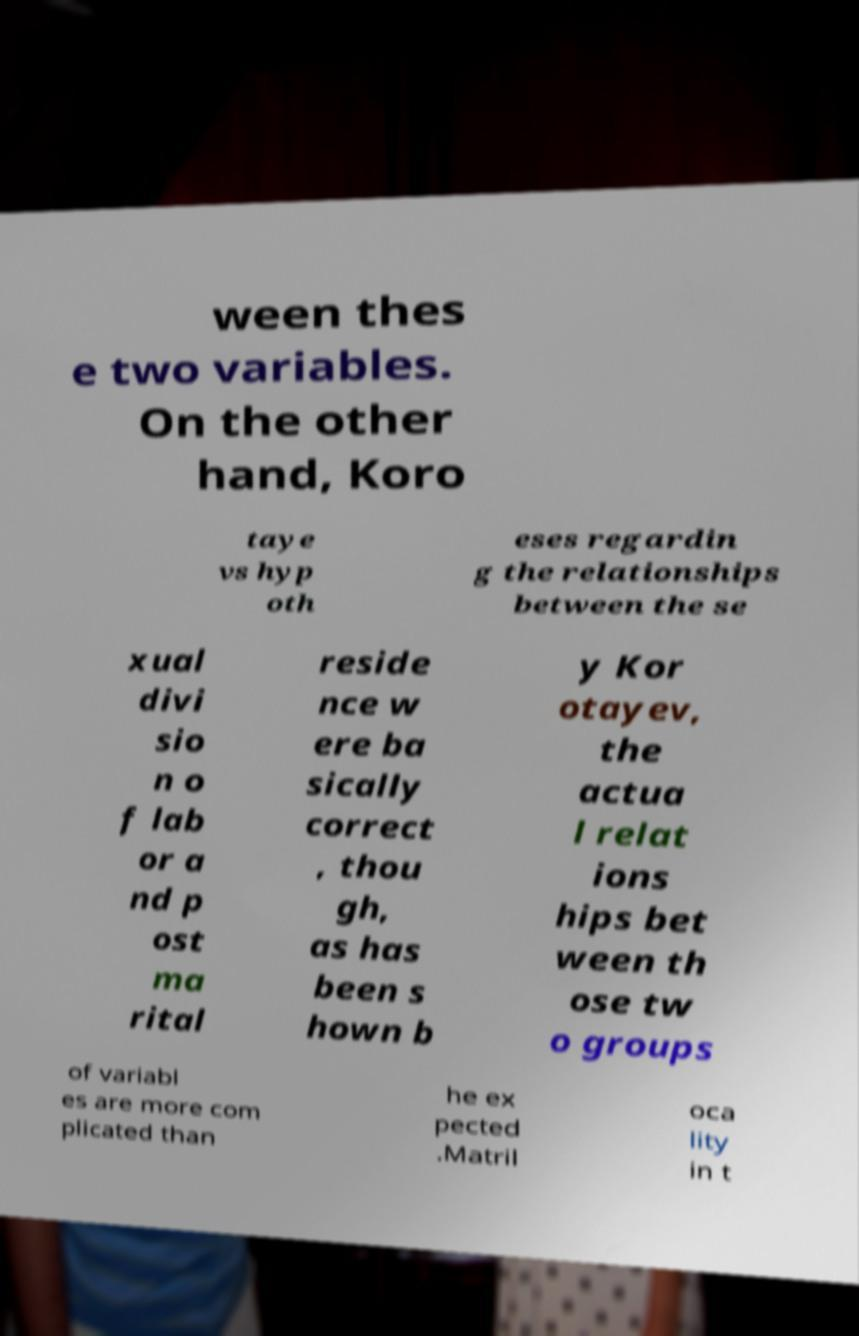Could you assist in decoding the text presented in this image and type it out clearly? ween thes e two variables. On the other hand, Koro taye vs hyp oth eses regardin g the relationships between the se xual divi sio n o f lab or a nd p ost ma rital reside nce w ere ba sically correct , thou gh, as has been s hown b y Kor otayev, the actua l relat ions hips bet ween th ose tw o groups of variabl es are more com plicated than he ex pected .Matril oca lity in t 